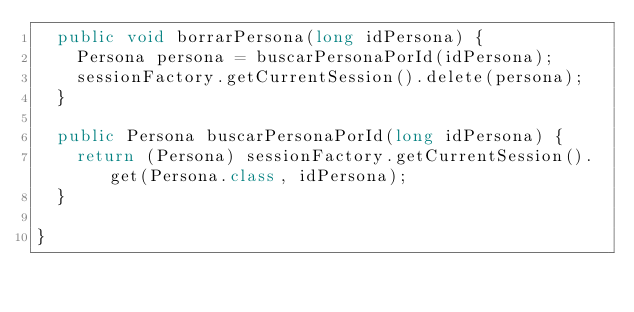<code> <loc_0><loc_0><loc_500><loc_500><_Java_>	public void borrarPersona(long idPersona) {
		Persona persona = buscarPersonaPorId(idPersona);
		sessionFactory.getCurrentSession().delete(persona);
	}

	public Persona buscarPersonaPorId(long idPersona) {
		return (Persona) sessionFactory.getCurrentSession().get(Persona.class, idPersona);
	}

}
</code> 